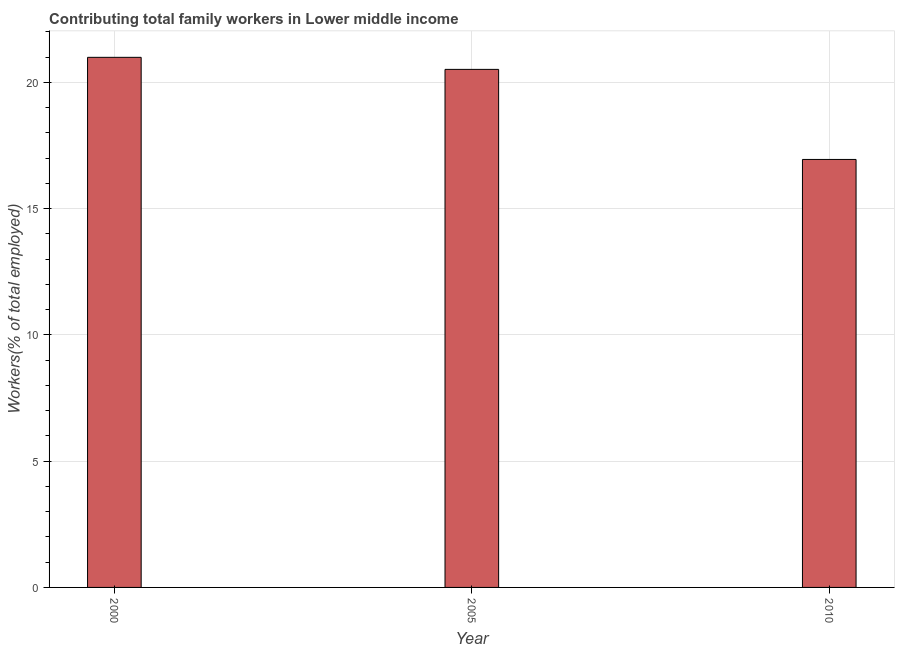Does the graph contain any zero values?
Offer a terse response. No. What is the title of the graph?
Provide a short and direct response. Contributing total family workers in Lower middle income. What is the label or title of the X-axis?
Offer a very short reply. Year. What is the label or title of the Y-axis?
Keep it short and to the point. Workers(% of total employed). What is the contributing family workers in 2000?
Give a very brief answer. 20.99. Across all years, what is the maximum contributing family workers?
Provide a short and direct response. 20.99. Across all years, what is the minimum contributing family workers?
Your answer should be very brief. 16.95. What is the sum of the contributing family workers?
Your answer should be compact. 58.45. What is the difference between the contributing family workers in 2005 and 2010?
Provide a succinct answer. 3.57. What is the average contributing family workers per year?
Your response must be concise. 19.48. What is the median contributing family workers?
Make the answer very short. 20.51. Do a majority of the years between 2000 and 2010 (inclusive) have contributing family workers greater than 14 %?
Make the answer very short. Yes. What is the ratio of the contributing family workers in 2005 to that in 2010?
Provide a short and direct response. 1.21. Is the difference between the contributing family workers in 2000 and 2010 greater than the difference between any two years?
Ensure brevity in your answer.  Yes. What is the difference between the highest and the second highest contributing family workers?
Give a very brief answer. 0.48. What is the difference between the highest and the lowest contributing family workers?
Make the answer very short. 4.04. In how many years, is the contributing family workers greater than the average contributing family workers taken over all years?
Your response must be concise. 2. How many bars are there?
Keep it short and to the point. 3. Are all the bars in the graph horizontal?
Your answer should be compact. No. How many years are there in the graph?
Provide a succinct answer. 3. What is the Workers(% of total employed) in 2000?
Offer a very short reply. 20.99. What is the Workers(% of total employed) of 2005?
Provide a succinct answer. 20.51. What is the Workers(% of total employed) in 2010?
Ensure brevity in your answer.  16.95. What is the difference between the Workers(% of total employed) in 2000 and 2005?
Provide a short and direct response. 0.48. What is the difference between the Workers(% of total employed) in 2000 and 2010?
Give a very brief answer. 4.04. What is the difference between the Workers(% of total employed) in 2005 and 2010?
Offer a very short reply. 3.57. What is the ratio of the Workers(% of total employed) in 2000 to that in 2005?
Give a very brief answer. 1.02. What is the ratio of the Workers(% of total employed) in 2000 to that in 2010?
Your answer should be compact. 1.24. What is the ratio of the Workers(% of total employed) in 2005 to that in 2010?
Make the answer very short. 1.21. 